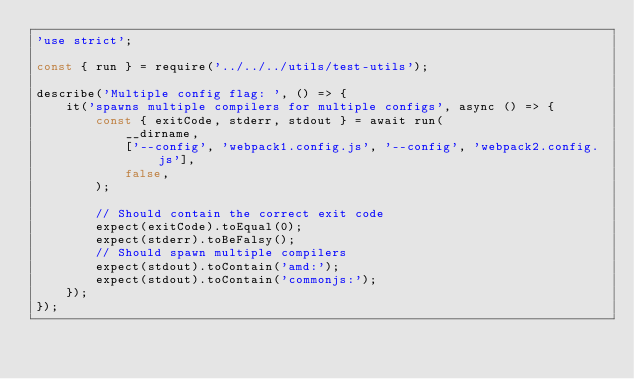<code> <loc_0><loc_0><loc_500><loc_500><_JavaScript_>'use strict';

const { run } = require('../../../utils/test-utils');

describe('Multiple config flag: ', () => {
    it('spawns multiple compilers for multiple configs', async () => {
        const { exitCode, stderr, stdout } = await run(
            __dirname,
            ['--config', 'webpack1.config.js', '--config', 'webpack2.config.js'],
            false,
        );

        // Should contain the correct exit code
        expect(exitCode).toEqual(0);
        expect(stderr).toBeFalsy();
        // Should spawn multiple compilers
        expect(stdout).toContain('amd:');
        expect(stdout).toContain('commonjs:');
    });
});
</code> 